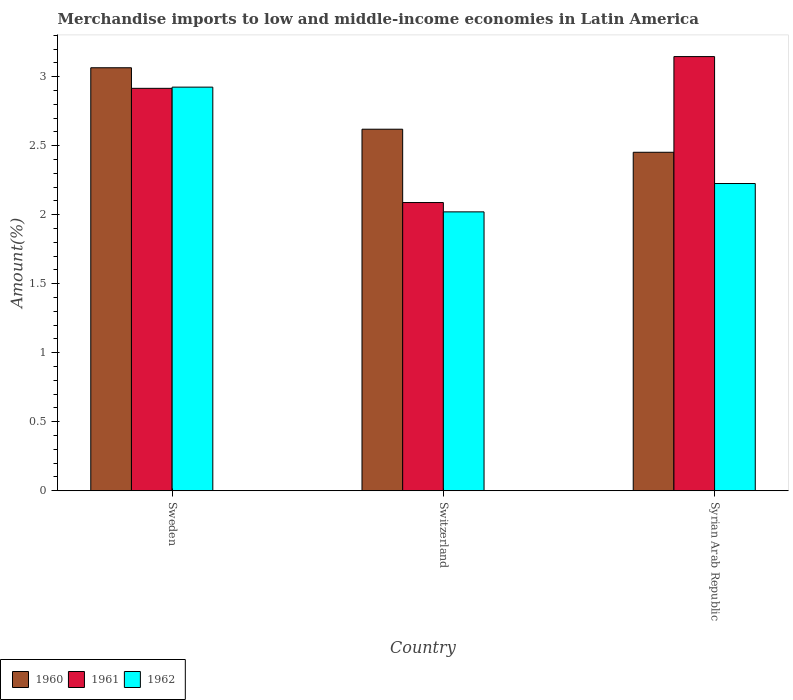How many different coloured bars are there?
Provide a short and direct response. 3. How many groups of bars are there?
Make the answer very short. 3. Are the number of bars per tick equal to the number of legend labels?
Offer a very short reply. Yes. How many bars are there on the 3rd tick from the left?
Offer a very short reply. 3. What is the label of the 3rd group of bars from the left?
Offer a very short reply. Syrian Arab Republic. What is the percentage of amount earned from merchandise imports in 1962 in Sweden?
Provide a short and direct response. 2.92. Across all countries, what is the maximum percentage of amount earned from merchandise imports in 1962?
Provide a succinct answer. 2.92. Across all countries, what is the minimum percentage of amount earned from merchandise imports in 1960?
Ensure brevity in your answer.  2.45. In which country was the percentage of amount earned from merchandise imports in 1961 maximum?
Your answer should be compact. Syrian Arab Republic. In which country was the percentage of amount earned from merchandise imports in 1962 minimum?
Your answer should be very brief. Switzerland. What is the total percentage of amount earned from merchandise imports in 1960 in the graph?
Your answer should be very brief. 8.14. What is the difference between the percentage of amount earned from merchandise imports in 1962 in Sweden and that in Syrian Arab Republic?
Provide a short and direct response. 0.7. What is the difference between the percentage of amount earned from merchandise imports in 1961 in Switzerland and the percentage of amount earned from merchandise imports in 1960 in Syrian Arab Republic?
Make the answer very short. -0.36. What is the average percentage of amount earned from merchandise imports in 1962 per country?
Provide a succinct answer. 2.39. What is the difference between the percentage of amount earned from merchandise imports of/in 1961 and percentage of amount earned from merchandise imports of/in 1960 in Switzerland?
Provide a short and direct response. -0.53. What is the ratio of the percentage of amount earned from merchandise imports in 1960 in Sweden to that in Switzerland?
Ensure brevity in your answer.  1.17. What is the difference between the highest and the second highest percentage of amount earned from merchandise imports in 1960?
Keep it short and to the point. -0.17. What is the difference between the highest and the lowest percentage of amount earned from merchandise imports in 1962?
Keep it short and to the point. 0.9. What does the 2nd bar from the right in Syrian Arab Republic represents?
Ensure brevity in your answer.  1961. Are all the bars in the graph horizontal?
Give a very brief answer. No. Are the values on the major ticks of Y-axis written in scientific E-notation?
Make the answer very short. No. Does the graph contain grids?
Offer a very short reply. No. Where does the legend appear in the graph?
Make the answer very short. Bottom left. What is the title of the graph?
Make the answer very short. Merchandise imports to low and middle-income economies in Latin America. What is the label or title of the Y-axis?
Provide a succinct answer. Amount(%). What is the Amount(%) in 1960 in Sweden?
Provide a succinct answer. 3.06. What is the Amount(%) of 1961 in Sweden?
Your answer should be very brief. 2.92. What is the Amount(%) in 1962 in Sweden?
Give a very brief answer. 2.92. What is the Amount(%) of 1960 in Switzerland?
Your answer should be compact. 2.62. What is the Amount(%) in 1961 in Switzerland?
Your answer should be very brief. 2.09. What is the Amount(%) of 1962 in Switzerland?
Offer a very short reply. 2.02. What is the Amount(%) of 1960 in Syrian Arab Republic?
Give a very brief answer. 2.45. What is the Amount(%) in 1961 in Syrian Arab Republic?
Give a very brief answer. 3.15. What is the Amount(%) of 1962 in Syrian Arab Republic?
Your response must be concise. 2.23. Across all countries, what is the maximum Amount(%) of 1960?
Offer a terse response. 3.06. Across all countries, what is the maximum Amount(%) in 1961?
Provide a short and direct response. 3.15. Across all countries, what is the maximum Amount(%) of 1962?
Offer a very short reply. 2.92. Across all countries, what is the minimum Amount(%) in 1960?
Provide a succinct answer. 2.45. Across all countries, what is the minimum Amount(%) of 1961?
Ensure brevity in your answer.  2.09. Across all countries, what is the minimum Amount(%) in 1962?
Give a very brief answer. 2.02. What is the total Amount(%) of 1960 in the graph?
Ensure brevity in your answer.  8.14. What is the total Amount(%) in 1961 in the graph?
Provide a short and direct response. 8.15. What is the total Amount(%) of 1962 in the graph?
Ensure brevity in your answer.  7.17. What is the difference between the Amount(%) of 1960 in Sweden and that in Switzerland?
Your answer should be very brief. 0.45. What is the difference between the Amount(%) in 1961 in Sweden and that in Switzerland?
Provide a succinct answer. 0.83. What is the difference between the Amount(%) in 1962 in Sweden and that in Switzerland?
Ensure brevity in your answer.  0.9. What is the difference between the Amount(%) of 1960 in Sweden and that in Syrian Arab Republic?
Your answer should be very brief. 0.61. What is the difference between the Amount(%) of 1961 in Sweden and that in Syrian Arab Republic?
Your answer should be compact. -0.23. What is the difference between the Amount(%) of 1962 in Sweden and that in Syrian Arab Republic?
Offer a very short reply. 0.7. What is the difference between the Amount(%) of 1960 in Switzerland and that in Syrian Arab Republic?
Your response must be concise. 0.17. What is the difference between the Amount(%) of 1961 in Switzerland and that in Syrian Arab Republic?
Give a very brief answer. -1.06. What is the difference between the Amount(%) in 1962 in Switzerland and that in Syrian Arab Republic?
Give a very brief answer. -0.21. What is the difference between the Amount(%) in 1960 in Sweden and the Amount(%) in 1961 in Switzerland?
Provide a succinct answer. 0.98. What is the difference between the Amount(%) in 1960 in Sweden and the Amount(%) in 1962 in Switzerland?
Offer a very short reply. 1.04. What is the difference between the Amount(%) of 1961 in Sweden and the Amount(%) of 1962 in Switzerland?
Your answer should be very brief. 0.89. What is the difference between the Amount(%) of 1960 in Sweden and the Amount(%) of 1961 in Syrian Arab Republic?
Provide a succinct answer. -0.08. What is the difference between the Amount(%) of 1960 in Sweden and the Amount(%) of 1962 in Syrian Arab Republic?
Keep it short and to the point. 0.84. What is the difference between the Amount(%) in 1961 in Sweden and the Amount(%) in 1962 in Syrian Arab Republic?
Your answer should be very brief. 0.69. What is the difference between the Amount(%) in 1960 in Switzerland and the Amount(%) in 1961 in Syrian Arab Republic?
Provide a short and direct response. -0.53. What is the difference between the Amount(%) in 1960 in Switzerland and the Amount(%) in 1962 in Syrian Arab Republic?
Offer a very short reply. 0.39. What is the difference between the Amount(%) in 1961 in Switzerland and the Amount(%) in 1962 in Syrian Arab Republic?
Keep it short and to the point. -0.14. What is the average Amount(%) of 1960 per country?
Ensure brevity in your answer.  2.71. What is the average Amount(%) of 1961 per country?
Your response must be concise. 2.72. What is the average Amount(%) of 1962 per country?
Provide a short and direct response. 2.39. What is the difference between the Amount(%) in 1960 and Amount(%) in 1961 in Sweden?
Provide a short and direct response. 0.15. What is the difference between the Amount(%) of 1960 and Amount(%) of 1962 in Sweden?
Ensure brevity in your answer.  0.14. What is the difference between the Amount(%) of 1961 and Amount(%) of 1962 in Sweden?
Make the answer very short. -0.01. What is the difference between the Amount(%) in 1960 and Amount(%) in 1961 in Switzerland?
Provide a succinct answer. 0.53. What is the difference between the Amount(%) in 1960 and Amount(%) in 1962 in Switzerland?
Ensure brevity in your answer.  0.6. What is the difference between the Amount(%) in 1961 and Amount(%) in 1962 in Switzerland?
Your answer should be compact. 0.07. What is the difference between the Amount(%) of 1960 and Amount(%) of 1961 in Syrian Arab Republic?
Ensure brevity in your answer.  -0.69. What is the difference between the Amount(%) in 1960 and Amount(%) in 1962 in Syrian Arab Republic?
Your answer should be compact. 0.23. What is the difference between the Amount(%) of 1961 and Amount(%) of 1962 in Syrian Arab Republic?
Ensure brevity in your answer.  0.92. What is the ratio of the Amount(%) in 1960 in Sweden to that in Switzerland?
Give a very brief answer. 1.17. What is the ratio of the Amount(%) in 1961 in Sweden to that in Switzerland?
Ensure brevity in your answer.  1.4. What is the ratio of the Amount(%) in 1962 in Sweden to that in Switzerland?
Your response must be concise. 1.45. What is the ratio of the Amount(%) of 1960 in Sweden to that in Syrian Arab Republic?
Give a very brief answer. 1.25. What is the ratio of the Amount(%) in 1961 in Sweden to that in Syrian Arab Republic?
Keep it short and to the point. 0.93. What is the ratio of the Amount(%) in 1962 in Sweden to that in Syrian Arab Republic?
Your answer should be very brief. 1.31. What is the ratio of the Amount(%) of 1960 in Switzerland to that in Syrian Arab Republic?
Provide a succinct answer. 1.07. What is the ratio of the Amount(%) of 1961 in Switzerland to that in Syrian Arab Republic?
Ensure brevity in your answer.  0.66. What is the ratio of the Amount(%) in 1962 in Switzerland to that in Syrian Arab Republic?
Your answer should be compact. 0.91. What is the difference between the highest and the second highest Amount(%) in 1960?
Your answer should be compact. 0.45. What is the difference between the highest and the second highest Amount(%) of 1961?
Keep it short and to the point. 0.23. What is the difference between the highest and the second highest Amount(%) in 1962?
Your answer should be very brief. 0.7. What is the difference between the highest and the lowest Amount(%) in 1960?
Your answer should be compact. 0.61. What is the difference between the highest and the lowest Amount(%) in 1961?
Provide a succinct answer. 1.06. What is the difference between the highest and the lowest Amount(%) of 1962?
Offer a terse response. 0.9. 